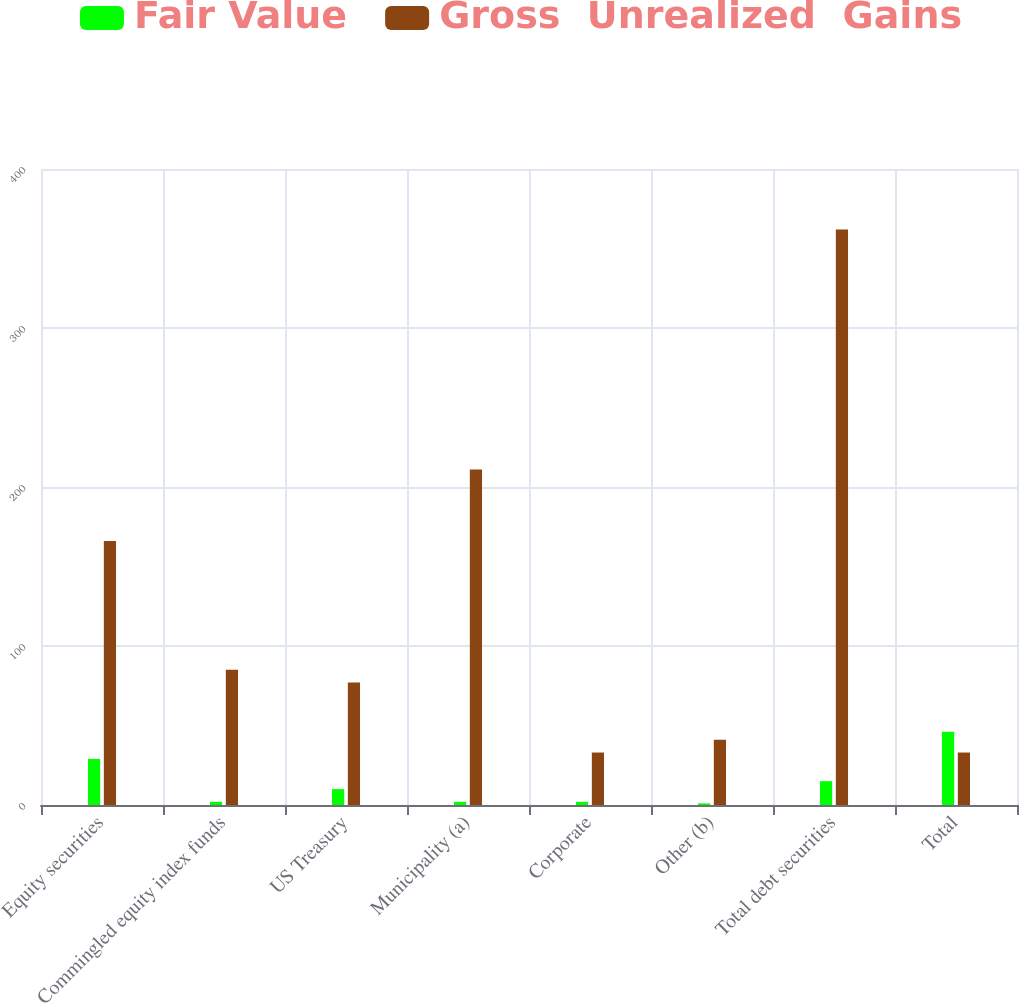<chart> <loc_0><loc_0><loc_500><loc_500><stacked_bar_chart><ecel><fcel>Equity securities<fcel>Commingled equity index funds<fcel>US Treasury<fcel>Municipality (a)<fcel>Corporate<fcel>Other (b)<fcel>Total debt securities<fcel>Total<nl><fcel>Fair Value<fcel>29<fcel>2<fcel>10<fcel>2<fcel>2<fcel>1<fcel>15<fcel>46<nl><fcel>Gross  Unrealized  Gains<fcel>166<fcel>85<fcel>77<fcel>211<fcel>33<fcel>41<fcel>362<fcel>33<nl></chart> 